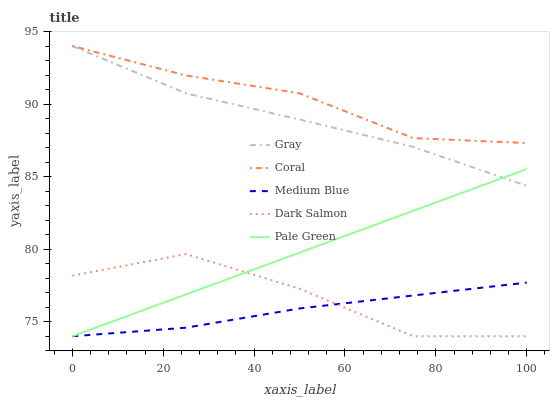Does Medium Blue have the minimum area under the curve?
Answer yes or no. Yes. Does Coral have the maximum area under the curve?
Answer yes or no. Yes. Does Pale Green have the minimum area under the curve?
Answer yes or no. No. Does Pale Green have the maximum area under the curve?
Answer yes or no. No. Is Pale Green the smoothest?
Answer yes or no. Yes. Is Dark Salmon the roughest?
Answer yes or no. Yes. Is Coral the smoothest?
Answer yes or no. No. Is Coral the roughest?
Answer yes or no. No. Does Pale Green have the lowest value?
Answer yes or no. Yes. Does Coral have the lowest value?
Answer yes or no. No. Does Coral have the highest value?
Answer yes or no. Yes. Does Pale Green have the highest value?
Answer yes or no. No. Is Pale Green less than Coral?
Answer yes or no. Yes. Is Gray greater than Medium Blue?
Answer yes or no. Yes. Does Dark Salmon intersect Pale Green?
Answer yes or no. Yes. Is Dark Salmon less than Pale Green?
Answer yes or no. No. Is Dark Salmon greater than Pale Green?
Answer yes or no. No. Does Pale Green intersect Coral?
Answer yes or no. No. 